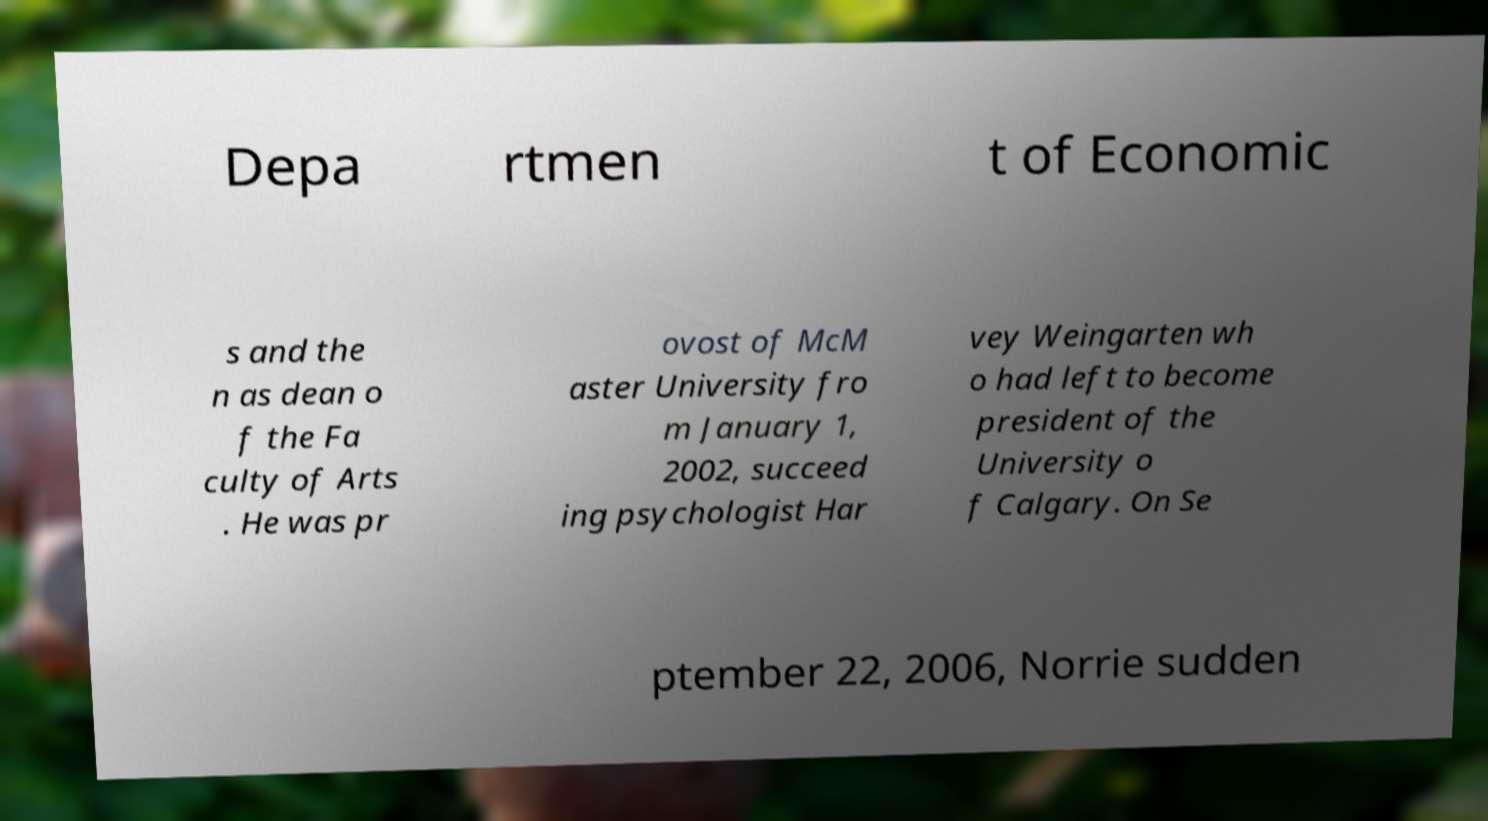What messages or text are displayed in this image? I need them in a readable, typed format. Depa rtmen t of Economic s and the n as dean o f the Fa culty of Arts . He was pr ovost of McM aster University fro m January 1, 2002, succeed ing psychologist Har vey Weingarten wh o had left to become president of the University o f Calgary. On Se ptember 22, 2006, Norrie sudden 